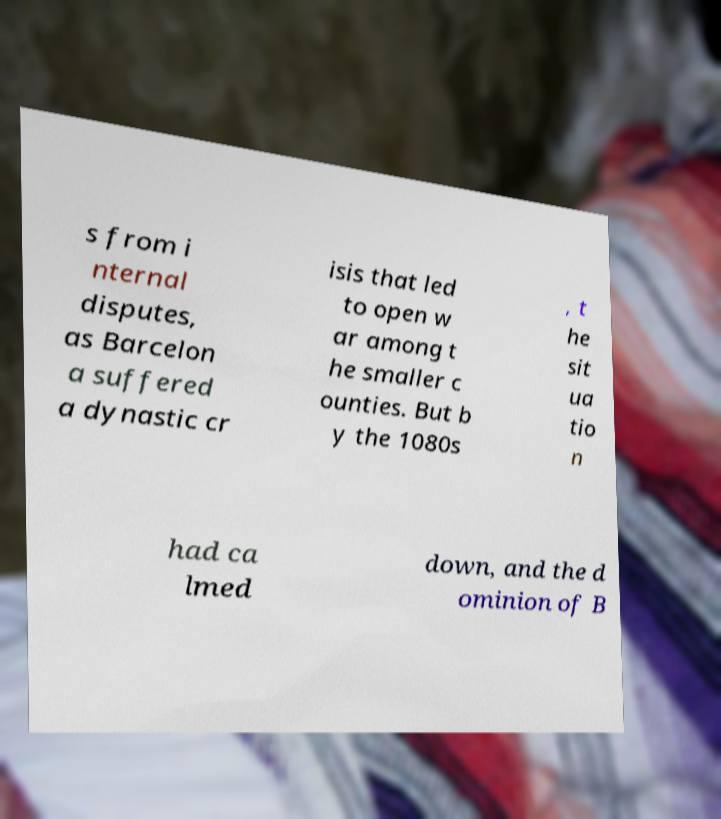Could you extract and type out the text from this image? s from i nternal disputes, as Barcelon a suffered a dynastic cr isis that led to open w ar among t he smaller c ounties. But b y the 1080s , t he sit ua tio n had ca lmed down, and the d ominion of B 